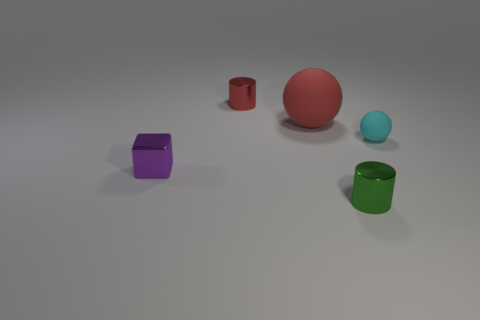What shapes do the objects have? The objects include two cubes, one sphere, and two cylinders. They all have distinctly different shapes, making the scene a study in geometric forms. Can you describe the colors of the objects? Certainly, the two cubes are purple and yellow respectively, the sphere is red, and the two cylinders are green and cyan. The objects display a range of colors that add visual interest to the composition. 